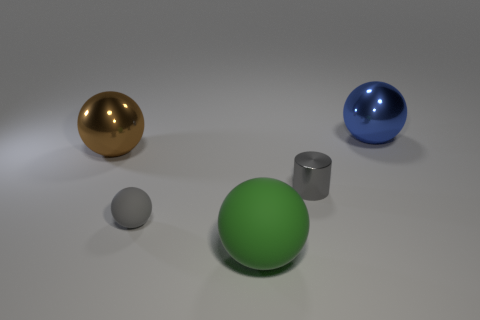There is a sphere on the right side of the big green thing; what size is it?
Ensure brevity in your answer.  Large. What shape is the shiny thing that is both to the left of the blue ball and right of the gray sphere?
Keep it short and to the point. Cylinder. There is a gray thing that is the same shape as the big brown metallic object; what is its size?
Ensure brevity in your answer.  Small. What number of blue things are the same material as the small gray cylinder?
Provide a short and direct response. 1. There is a tiny rubber thing; is it the same color as the tiny object behind the tiny gray rubber ball?
Your answer should be compact. Yes. Are there more small metallic cylinders than small red things?
Keep it short and to the point. Yes. What color is the cylinder?
Ensure brevity in your answer.  Gray. Do the matte thing on the left side of the large matte thing and the cylinder have the same color?
Ensure brevity in your answer.  Yes. What material is the small cylinder that is the same color as the small rubber thing?
Your response must be concise. Metal. How many metallic cylinders are the same color as the tiny rubber object?
Ensure brevity in your answer.  1. 